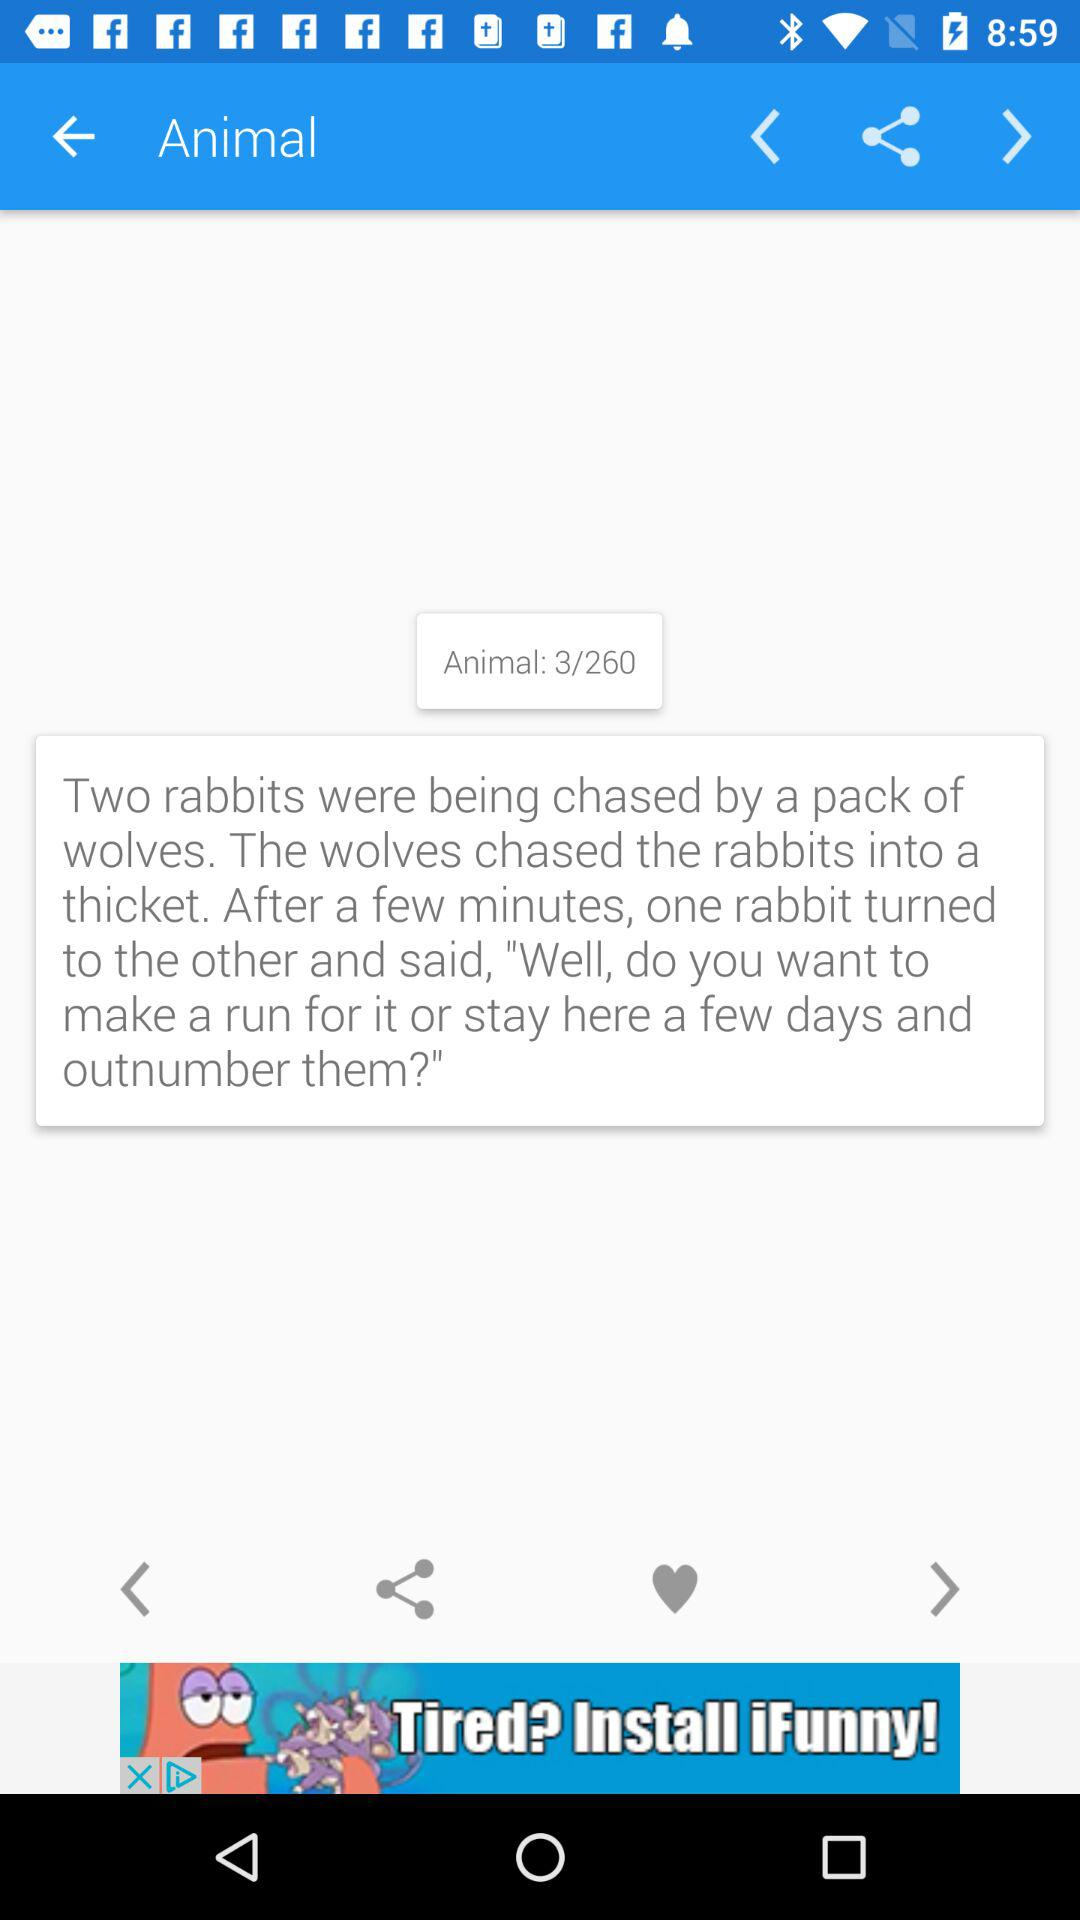How many total characters can be used?
When the provided information is insufficient, respond with <no answer>. <no answer> 